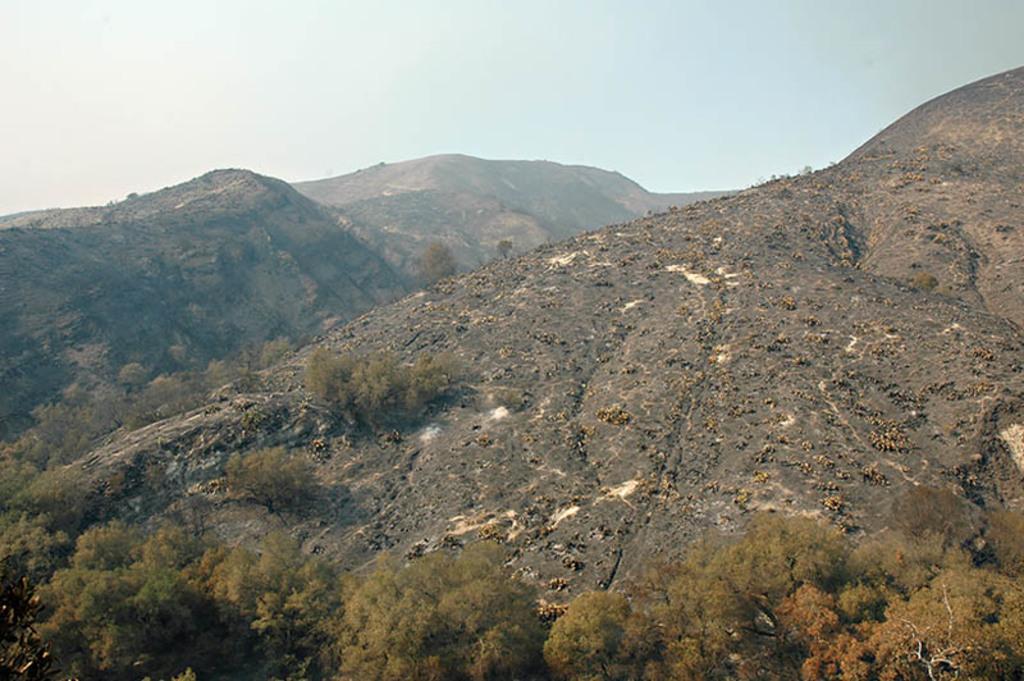Can you describe this image briefly? In this image I can see few trees in green color. In the background I can see the mountains and the sky is in blue and white color. 